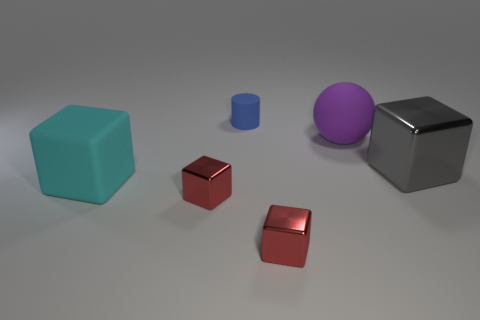Subtract all gray cubes. How many cubes are left? 3 Subtract all red cubes. How many cubes are left? 2 Add 4 blue rubber spheres. How many objects exist? 10 Subtract all cubes. How many objects are left? 2 Subtract 1 blocks. How many blocks are left? 3 Subtract all red balls. How many purple blocks are left? 0 Add 5 big gray metallic blocks. How many big gray metallic blocks are left? 6 Add 2 gray objects. How many gray objects exist? 3 Subtract 0 gray cylinders. How many objects are left? 6 Subtract all cyan cubes. Subtract all red cylinders. How many cubes are left? 3 